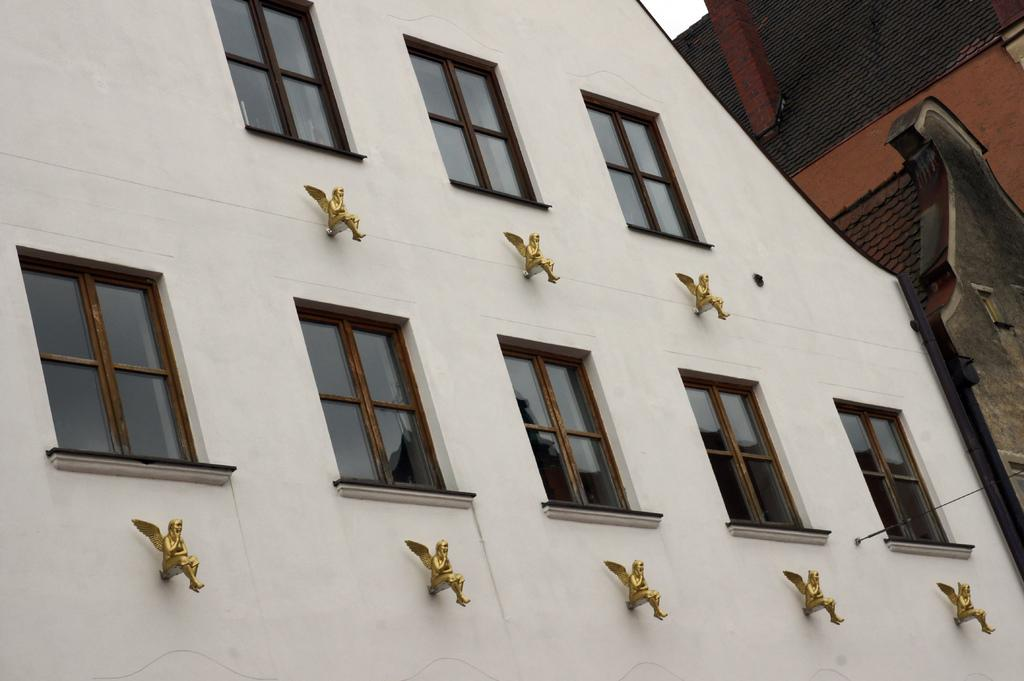What type of wall is visible in the image? There is a wall with glass windows in the image. What other architectural features can be seen in the image? There are statues, roofs, and a chimney in the image. Can you describe the wall's material or construction? The wall has glass windows, which suggests it is made of a material that allows for transparency. What type of vegetable is being used as a horn in the image? There is no vegetable or horn present in the image. 